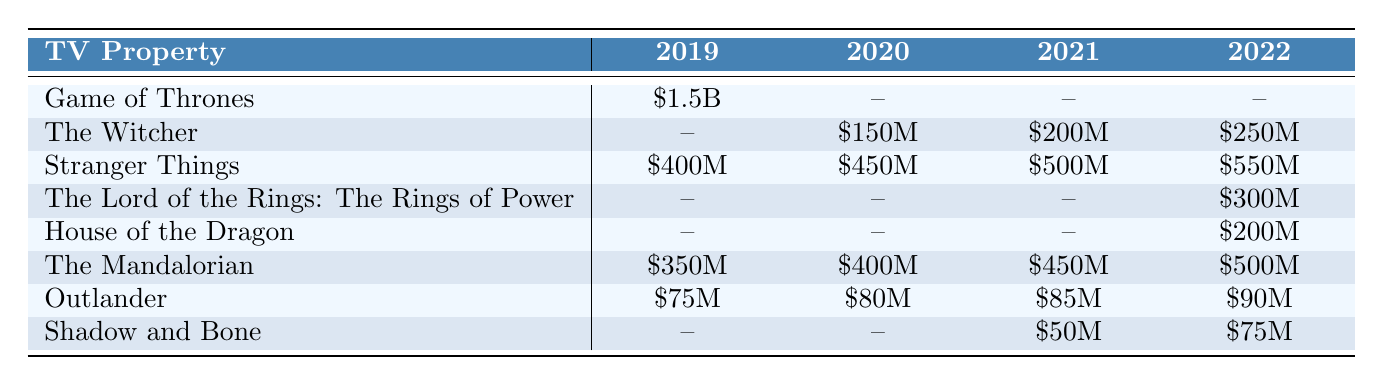What's the total merchandise sales figure for "Stranger Things"? From the table, the sales figures for "Stranger Things" over the years are \$400M (2019), \$450M (2020), \$500M (2021), and \$550M (2022). Adding these values together gives: \$400M + \$450M + \$500M + \$550M = \$1900M.
Answer: \$1900M Which TV property had sales figures in 2022? Looking at the 2022 column in the table, the properties with sales figures are "Stranger Things" (\$550M), "The Lord of the Rings: The Rings of Power" (\$300M), "House of the Dragon" (\$200M), "The Mandalorian" (\$500M), and "Shadow and Bone" (\$75M).
Answer: 5 properties What is the merchandise sales figure for "House of the Dragon" in 2020? In the 2020 column under "House of the Dragon," the value is marked as "--", which indicates there were no sales figures reported for that year.
Answer: No sales figure What was the year with the highest sales figure for "The Mandalorian"? The table shows sales figures for "The Mandalorian" as \$350M (2019), \$400M (2020), \$450M (2021), and \$500M (2022). The highest figure is \$500M in 2022.
Answer: 2022 What is the average merchandise sales figure for "The Witcher" from 2020 to 2022? The sales figures for "The Witcher" from 2020 to 2022 are \$150M (2020), \$200M (2021), and \$250M (2022). To find the average, sum these values: \$150M + \$200M + \$250M = \$600M, then divide by 3, resulting in \$600M / 3 = \$200M.
Answer: \$200M Was there any merchandise sales figure for "Game of Thrones" in 2020? The table shows that the sales figure for "Game of Thrones" in 2020 is marked as "--", meaning there was no merchandise reported for that year.
Answer: No Which property had the lowest merchandise sales in 2019? Reviewing the 2019 column in the table, "The Witcher," "The Lord of the Rings: The Rings of Power," "House of the Dragon," "Outlander," and "Shadow and Bone" all have sales figures marked as "--", while "Game of Thrones" has \$1.5B. The lowest reported value is \$75M for "Outlander."
Answer: "Outlander" What is the difference in merchandise sales between "Stranger Things" in 2021 and "The Lord of the Rings: The Rings of Power" in 2022? "Stranger Things" has \$500M in 2021, while "The Lord of the Rings: The Rings of Power" has \$300M in 2022. The difference in sales is \$500M - \$300M = \$200M.
Answer: \$200M Which two properties had the same merchandise sales figures in 2019? Checking the 2019 column, "The Witcher," "The Lord of the Rings: The Rings of Power," "House of the Dragon," "Outlander," and "Shadow and Bone" have no sales figures (marked as "--"), while only "Game of Thrones" had \$1.5B. Therefore, no two properties share the same sales figure in 2019.
Answer: None What is the total merchandise sales figures for all properties in 2022? The sales figures in 2022 from the table are: "Stranger Things" (\$550M), "The Lord of the Rings: The Rings of Power" (\$300M), "House of the Dragon" (\$200M), "The Mandalorian" (\$500M), and "Shadow and Bone" (\$75M). Adding these values gives: \$550M + \$300M + \$200M + \$500M + \$75M = \$1625M.
Answer: \$1625M 